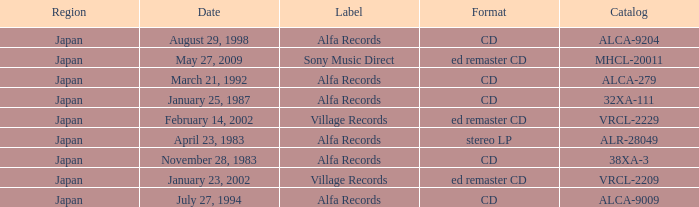What is the format of the date February 14, 2002? Ed remaster cd. 